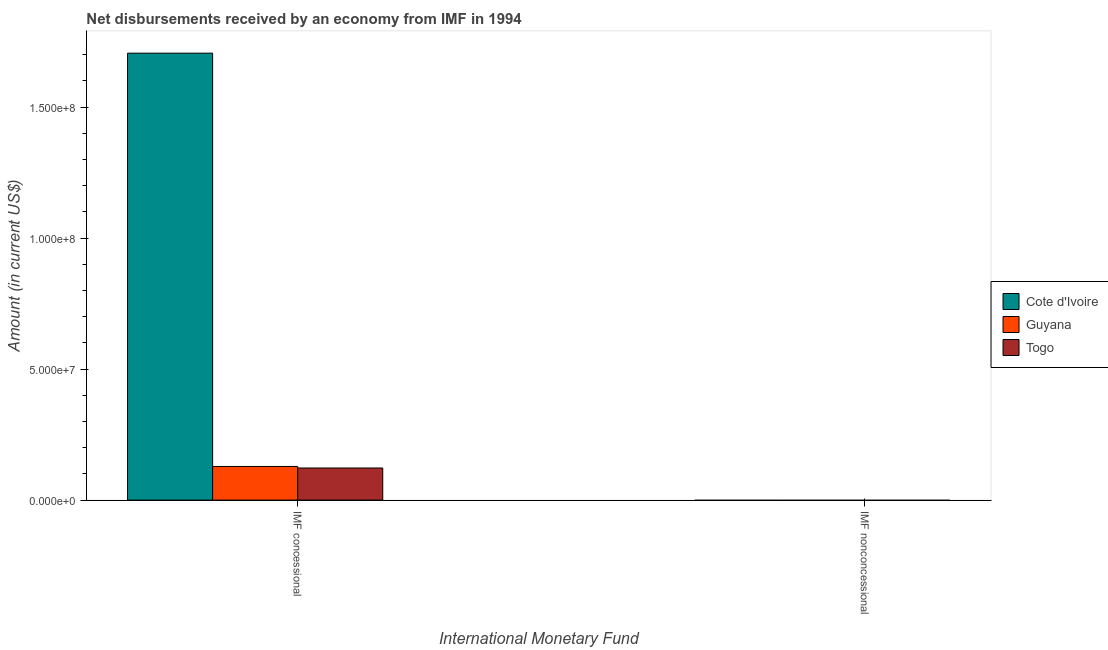Are the number of bars per tick equal to the number of legend labels?
Give a very brief answer. No. Are the number of bars on each tick of the X-axis equal?
Provide a succinct answer. No. How many bars are there on the 2nd tick from the left?
Ensure brevity in your answer.  0. How many bars are there on the 2nd tick from the right?
Give a very brief answer. 3. What is the label of the 1st group of bars from the left?
Your response must be concise. IMF concessional. What is the net non concessional disbursements from imf in Cote d'Ivoire?
Your answer should be very brief. 0. Across all countries, what is the maximum net concessional disbursements from imf?
Offer a very short reply. 1.71e+08. Across all countries, what is the minimum net concessional disbursements from imf?
Ensure brevity in your answer.  1.23e+07. In which country was the net concessional disbursements from imf maximum?
Ensure brevity in your answer.  Cote d'Ivoire. What is the total net concessional disbursements from imf in the graph?
Make the answer very short. 1.96e+08. What is the difference between the net concessional disbursements from imf in Guyana and that in Togo?
Your response must be concise. 5.78e+05. What is the difference between the net concessional disbursements from imf in Cote d'Ivoire and the net non concessional disbursements from imf in Togo?
Your answer should be compact. 1.71e+08. In how many countries, is the net non concessional disbursements from imf greater than 10000000 US$?
Keep it short and to the point. 0. What is the ratio of the net concessional disbursements from imf in Togo to that in Cote d'Ivoire?
Offer a terse response. 0.07. Is the net concessional disbursements from imf in Togo less than that in Guyana?
Make the answer very short. Yes. How many bars are there?
Offer a very short reply. 3. Are all the bars in the graph horizontal?
Your answer should be compact. No. How are the legend labels stacked?
Your answer should be very brief. Vertical. What is the title of the graph?
Your answer should be very brief. Net disbursements received by an economy from IMF in 1994. What is the label or title of the X-axis?
Your answer should be very brief. International Monetary Fund. What is the Amount (in current US$) in Cote d'Ivoire in IMF concessional?
Your response must be concise. 1.71e+08. What is the Amount (in current US$) in Guyana in IMF concessional?
Provide a short and direct response. 1.28e+07. What is the Amount (in current US$) of Togo in IMF concessional?
Your answer should be compact. 1.23e+07. What is the Amount (in current US$) of Guyana in IMF nonconcessional?
Provide a short and direct response. 0. Across all International Monetary Fund, what is the maximum Amount (in current US$) of Cote d'Ivoire?
Offer a very short reply. 1.71e+08. Across all International Monetary Fund, what is the maximum Amount (in current US$) of Guyana?
Ensure brevity in your answer.  1.28e+07. Across all International Monetary Fund, what is the maximum Amount (in current US$) in Togo?
Give a very brief answer. 1.23e+07. Across all International Monetary Fund, what is the minimum Amount (in current US$) in Cote d'Ivoire?
Your answer should be compact. 0. Across all International Monetary Fund, what is the minimum Amount (in current US$) of Togo?
Your answer should be compact. 0. What is the total Amount (in current US$) in Cote d'Ivoire in the graph?
Your response must be concise. 1.71e+08. What is the total Amount (in current US$) of Guyana in the graph?
Give a very brief answer. 1.28e+07. What is the total Amount (in current US$) in Togo in the graph?
Provide a short and direct response. 1.23e+07. What is the average Amount (in current US$) of Cote d'Ivoire per International Monetary Fund?
Ensure brevity in your answer.  8.53e+07. What is the average Amount (in current US$) of Guyana per International Monetary Fund?
Provide a short and direct response. 6.42e+06. What is the average Amount (in current US$) of Togo per International Monetary Fund?
Provide a succinct answer. 6.13e+06. What is the difference between the Amount (in current US$) in Cote d'Ivoire and Amount (in current US$) in Guyana in IMF concessional?
Offer a terse response. 1.58e+08. What is the difference between the Amount (in current US$) in Cote d'Ivoire and Amount (in current US$) in Togo in IMF concessional?
Offer a very short reply. 1.58e+08. What is the difference between the Amount (in current US$) of Guyana and Amount (in current US$) of Togo in IMF concessional?
Your answer should be compact. 5.78e+05. What is the difference between the highest and the lowest Amount (in current US$) of Cote d'Ivoire?
Give a very brief answer. 1.71e+08. What is the difference between the highest and the lowest Amount (in current US$) in Guyana?
Your answer should be very brief. 1.28e+07. What is the difference between the highest and the lowest Amount (in current US$) of Togo?
Your response must be concise. 1.23e+07. 